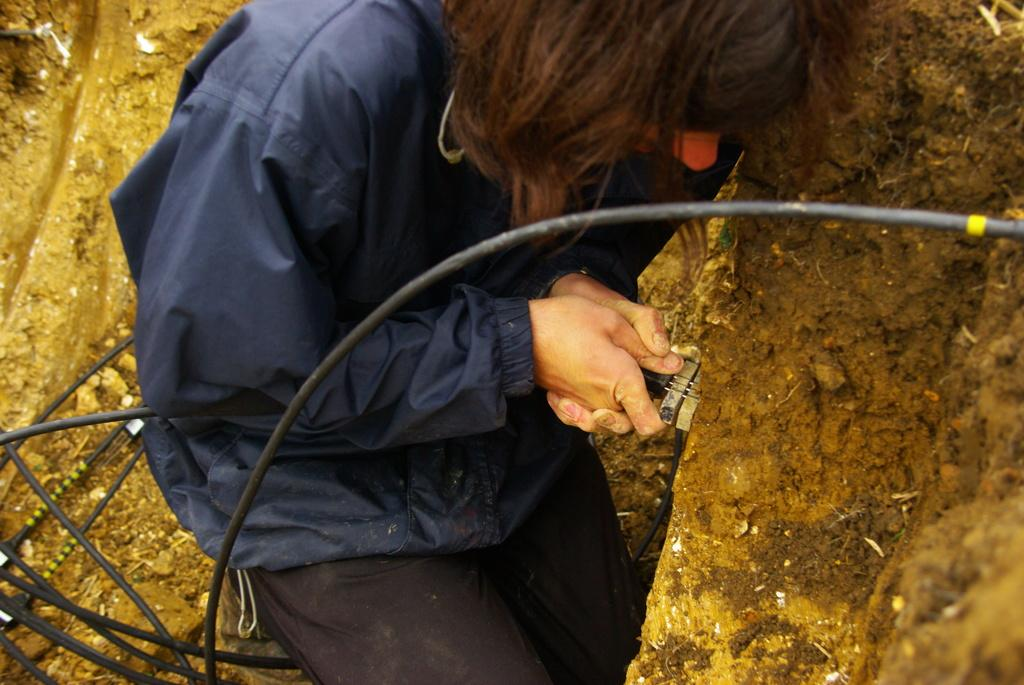What is the person in the image doing? The person is sitting on the mud in the image. What else can be seen in the image besides the person? Cable wires are present in the image. What type of religious ceremony is taking place in the image? There is no indication of a religious ceremony in the image; it only shows a person sitting on the mud and cable wires. 